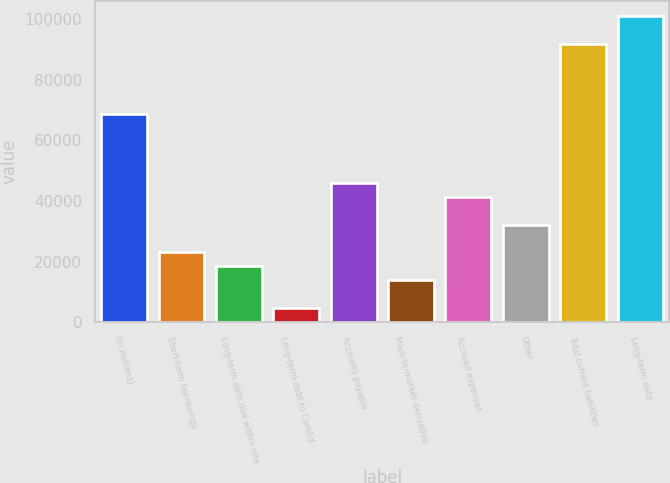Convert chart. <chart><loc_0><loc_0><loc_500><loc_500><bar_chart><fcel>(in millions)<fcel>Short-term borrowings<fcel>Long-term debt due within one<fcel>Long-term debt to ComEd<fcel>Accounts payable<fcel>Mark-to-market derivative<fcel>Accrued expenses<fcel>Other<fcel>Total current liabilities<fcel>Long-term debt<nl><fcel>68797.5<fcel>22990.5<fcel>18409.8<fcel>4667.7<fcel>45894<fcel>13829.1<fcel>41313.3<fcel>32151.9<fcel>91701<fcel>100862<nl></chart> 